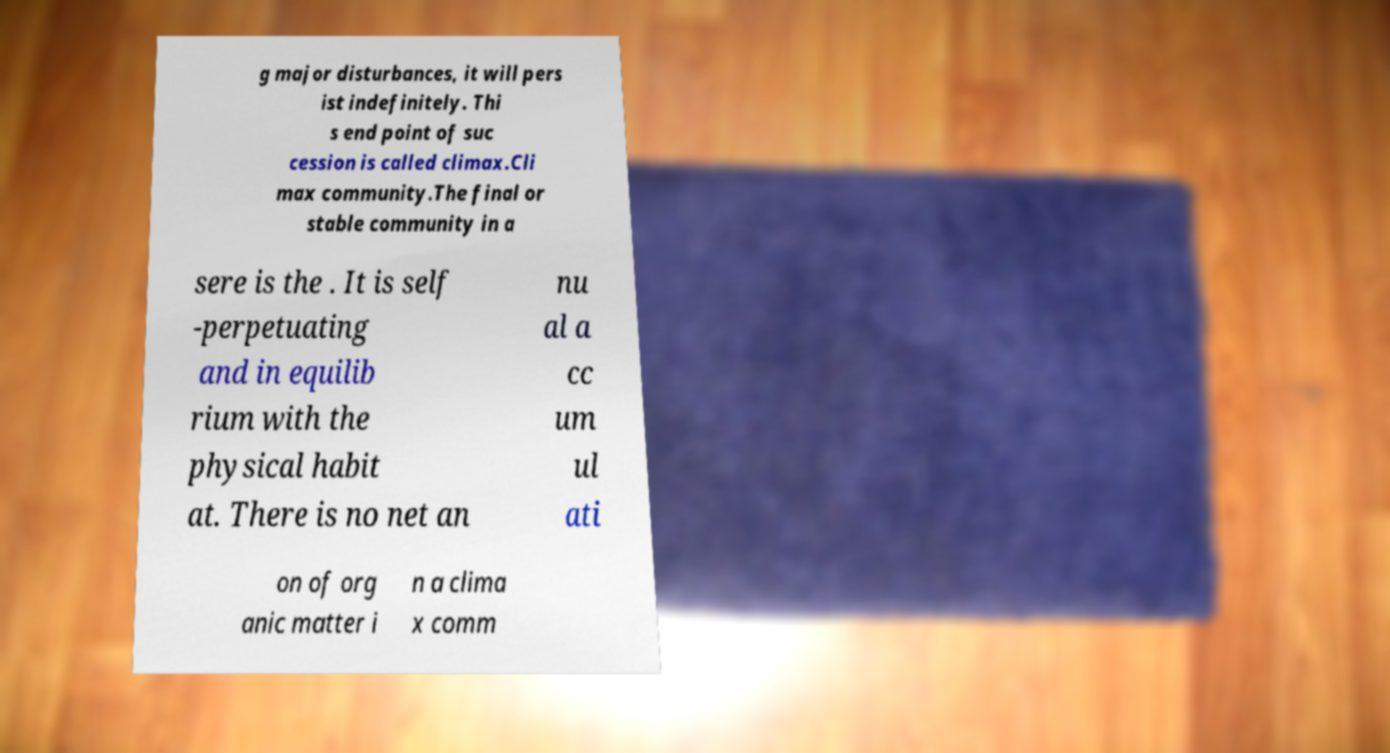Please read and relay the text visible in this image. What does it say? g major disturbances, it will pers ist indefinitely. Thi s end point of suc cession is called climax.Cli max community.The final or stable community in a sere is the . It is self -perpetuating and in equilib rium with the physical habit at. There is no net an nu al a cc um ul ati on of org anic matter i n a clima x comm 